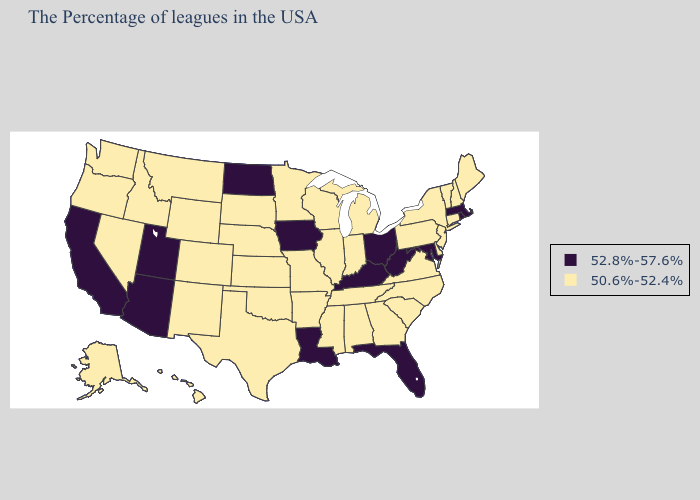What is the highest value in states that border Colorado?
Give a very brief answer. 52.8%-57.6%. Does Connecticut have the highest value in the Northeast?
Keep it brief. No. What is the lowest value in the MidWest?
Give a very brief answer. 50.6%-52.4%. Does the map have missing data?
Short answer required. No. What is the highest value in the South ?
Give a very brief answer. 52.8%-57.6%. What is the highest value in the USA?
Quick response, please. 52.8%-57.6%. What is the highest value in the USA?
Be succinct. 52.8%-57.6%. Name the states that have a value in the range 52.8%-57.6%?
Keep it brief. Massachusetts, Rhode Island, Maryland, West Virginia, Ohio, Florida, Kentucky, Louisiana, Iowa, North Dakota, Utah, Arizona, California. Does the map have missing data?
Give a very brief answer. No. Does the first symbol in the legend represent the smallest category?
Give a very brief answer. No. Does Oregon have the lowest value in the West?
Give a very brief answer. Yes. What is the highest value in states that border New York?
Be succinct. 52.8%-57.6%. What is the value of New York?
Give a very brief answer. 50.6%-52.4%. Among the states that border Nebraska , which have the highest value?
Keep it brief. Iowa. 